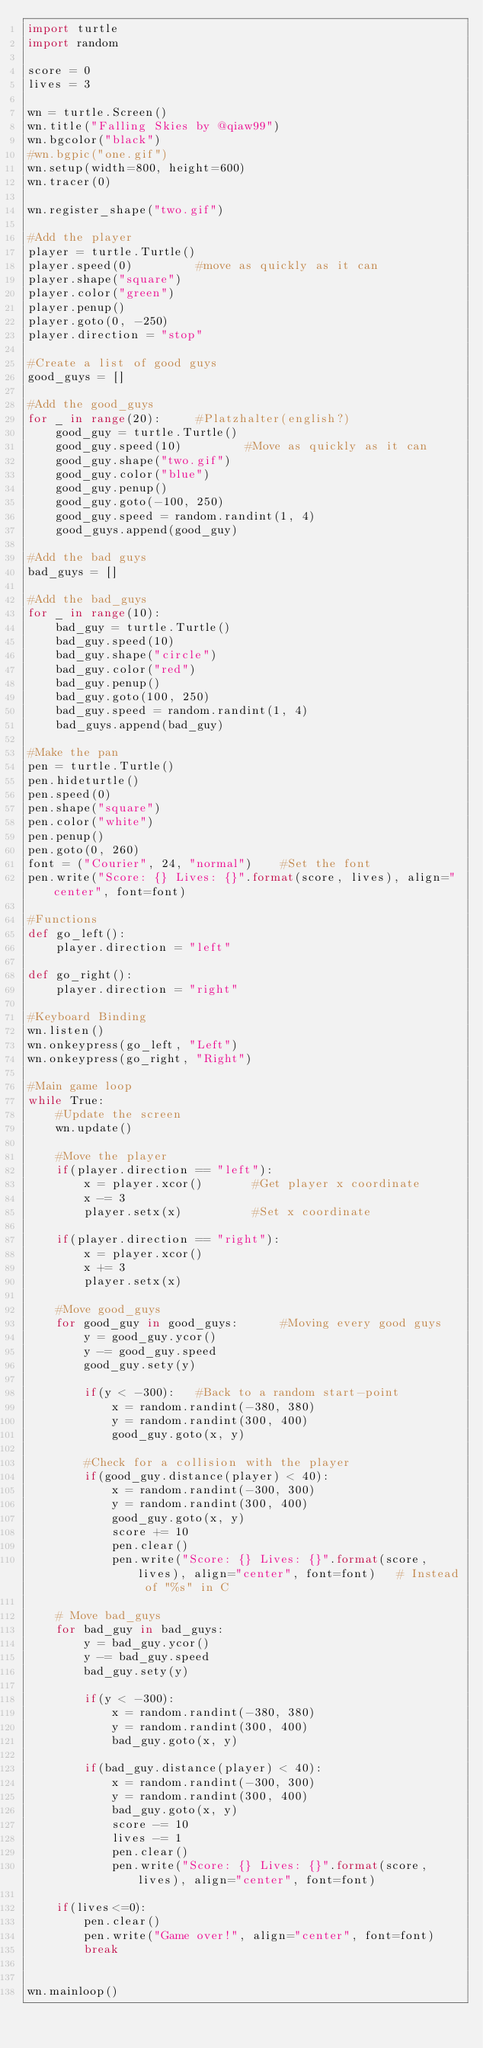Convert code to text. <code><loc_0><loc_0><loc_500><loc_500><_Python_>import turtle
import random

score = 0
lives = 3

wn = turtle.Screen()
wn.title("Falling Skies by @qiaw99")
wn.bgcolor("black")
#wn.bgpic("one.gif")
wn.setup(width=800, height=600)
wn.tracer(0)

wn.register_shape("two.gif")

#Add the player
player = turtle.Turtle()
player.speed(0)         #move as quickly as it can
player.shape("square")
player.color("green")
player.penup()
player.goto(0, -250)
player.direction = "stop"

#Create a list of good guys
good_guys = []

#Add the good_guys
for _ in range(20):     #Platzhalter(english?)
    good_guy = turtle.Turtle()
    good_guy.speed(10)         #Move as quickly as it can
    good_guy.shape("two.gif")
    good_guy.color("blue")
    good_guy.penup()
    good_guy.goto(-100, 250)
    good_guy.speed = random.randint(1, 4)
    good_guys.append(good_guy)

#Add the bad guys
bad_guys = []

#Add the bad_guys
for _ in range(10):
    bad_guy = turtle.Turtle()
    bad_guy.speed(10)
    bad_guy.shape("circle")
    bad_guy.color("red")
    bad_guy.penup()
    bad_guy.goto(100, 250)
    bad_guy.speed = random.randint(1, 4)
    bad_guys.append(bad_guy)

#Make the pan
pen = turtle.Turtle()
pen.hideturtle()
pen.speed(0)
pen.shape("square")
pen.color("white")
pen.penup()
pen.goto(0, 260)
font = ("Courier", 24, "normal")    #Set the font
pen.write("Score: {} Lives: {}".format(score, lives), align="center", font=font)

#Functions
def go_left():
    player.direction = "left"

def go_right():
    player.direction = "right"

#Keyboard Binding
wn.listen()
wn.onkeypress(go_left, "Left")
wn.onkeypress(go_right, "Right")

#Main game loop
while True:
    #Update the screen
    wn.update()

    #Move the player
    if(player.direction == "left"):
        x = player.xcor()       #Get player x coordinate
        x -= 3
        player.setx(x)          #Set x coordinate

    if(player.direction == "right"):
        x = player.xcor()
        x += 3
        player.setx(x)

    #Move good_guys
    for good_guy in good_guys:      #Moving every good guys
        y = good_guy.ycor()
        y -= good_guy.speed
        good_guy.sety(y)

        if(y < -300):   #Back to a random start-point
            x = random.randint(-380, 380)
            y = random.randint(300, 400)
            good_guy.goto(x, y)

        #Check for a collision with the player
        if(good_guy.distance(player) < 40):
            x = random.randint(-300, 300)
            y = random.randint(300, 400)
            good_guy.goto(x, y)
            score += 10
            pen.clear()
            pen.write("Score: {} Lives: {}".format(score, lives), align="center", font=font)   # Instead of "%s" in C

    # Move bad_guys
    for bad_guy in bad_guys:
        y = bad_guy.ycor()
        y -= bad_guy.speed
        bad_guy.sety(y)

        if(y < -300):
            x = random.randint(-380, 380)
            y = random.randint(300, 400)
            bad_guy.goto(x, y)

        if(bad_guy.distance(player) < 40):
            x = random.randint(-300, 300)
            y = random.randint(300, 400)
            bad_guy.goto(x, y)
            score -= 10
            lives -= 1
            pen.clear()
            pen.write("Score: {} Lives: {}".format(score, lives), align="center", font=font)

    if(lives<=0):
        pen.clear()
        pen.write("Game over!", align="center", font=font)
        break


wn.mainloop()
</code> 